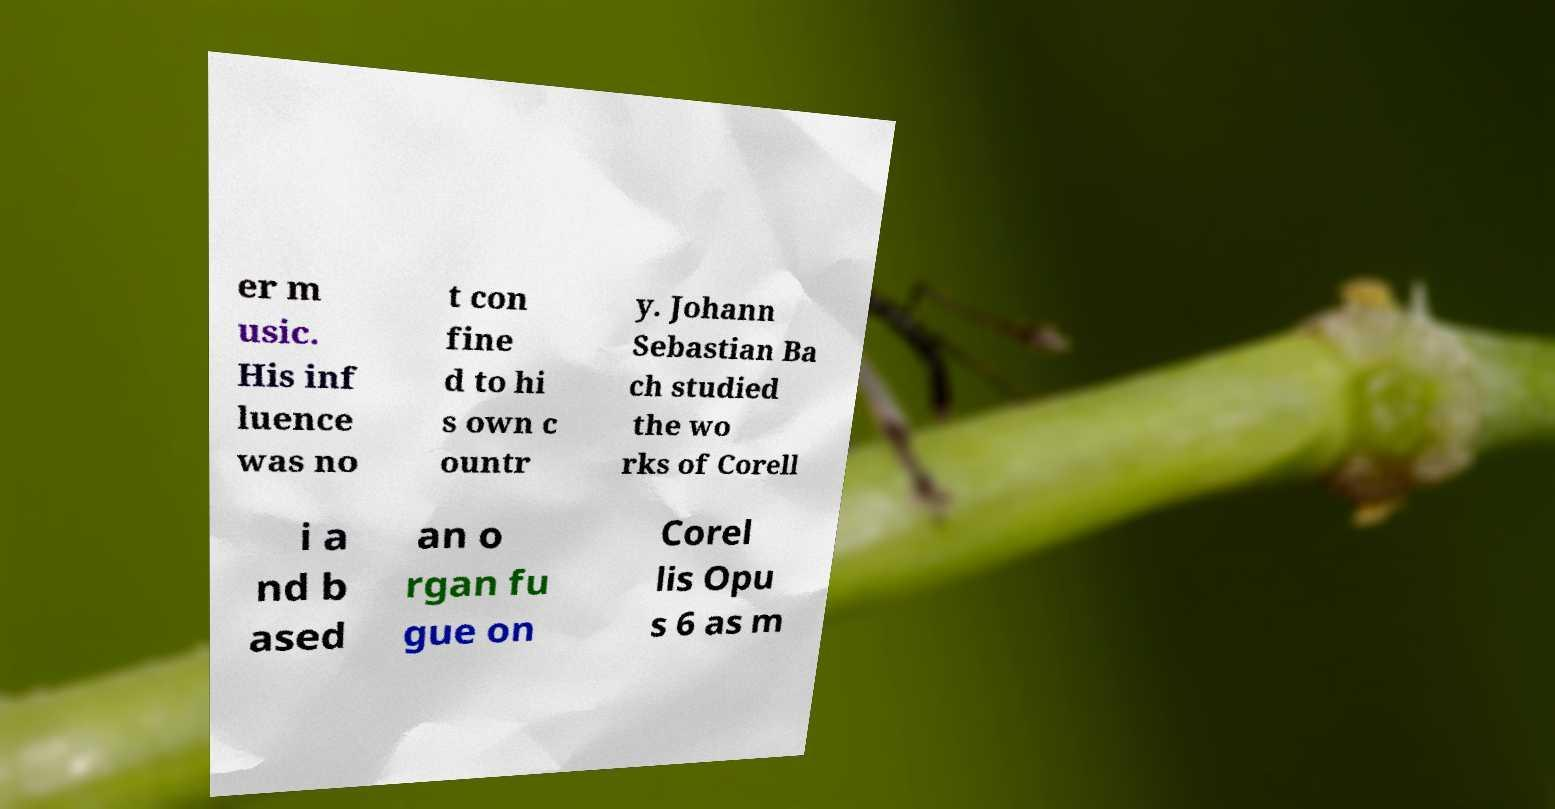What messages or text are displayed in this image? I need them in a readable, typed format. er m usic. His inf luence was no t con fine d to hi s own c ountr y. Johann Sebastian Ba ch studied the wo rks of Corell i a nd b ased an o rgan fu gue on Corel lis Opu s 6 as m 